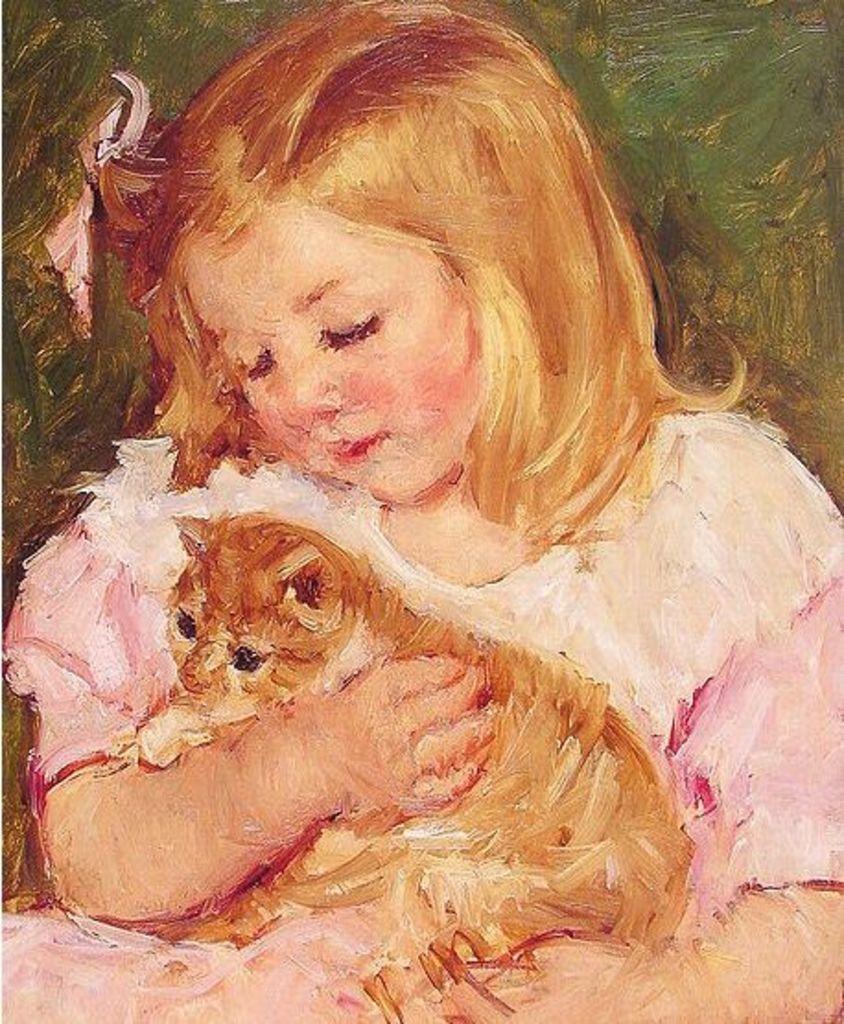Could you give a brief overview of what you see in this image? This is a painting and here we can see a kid holding a cat. 